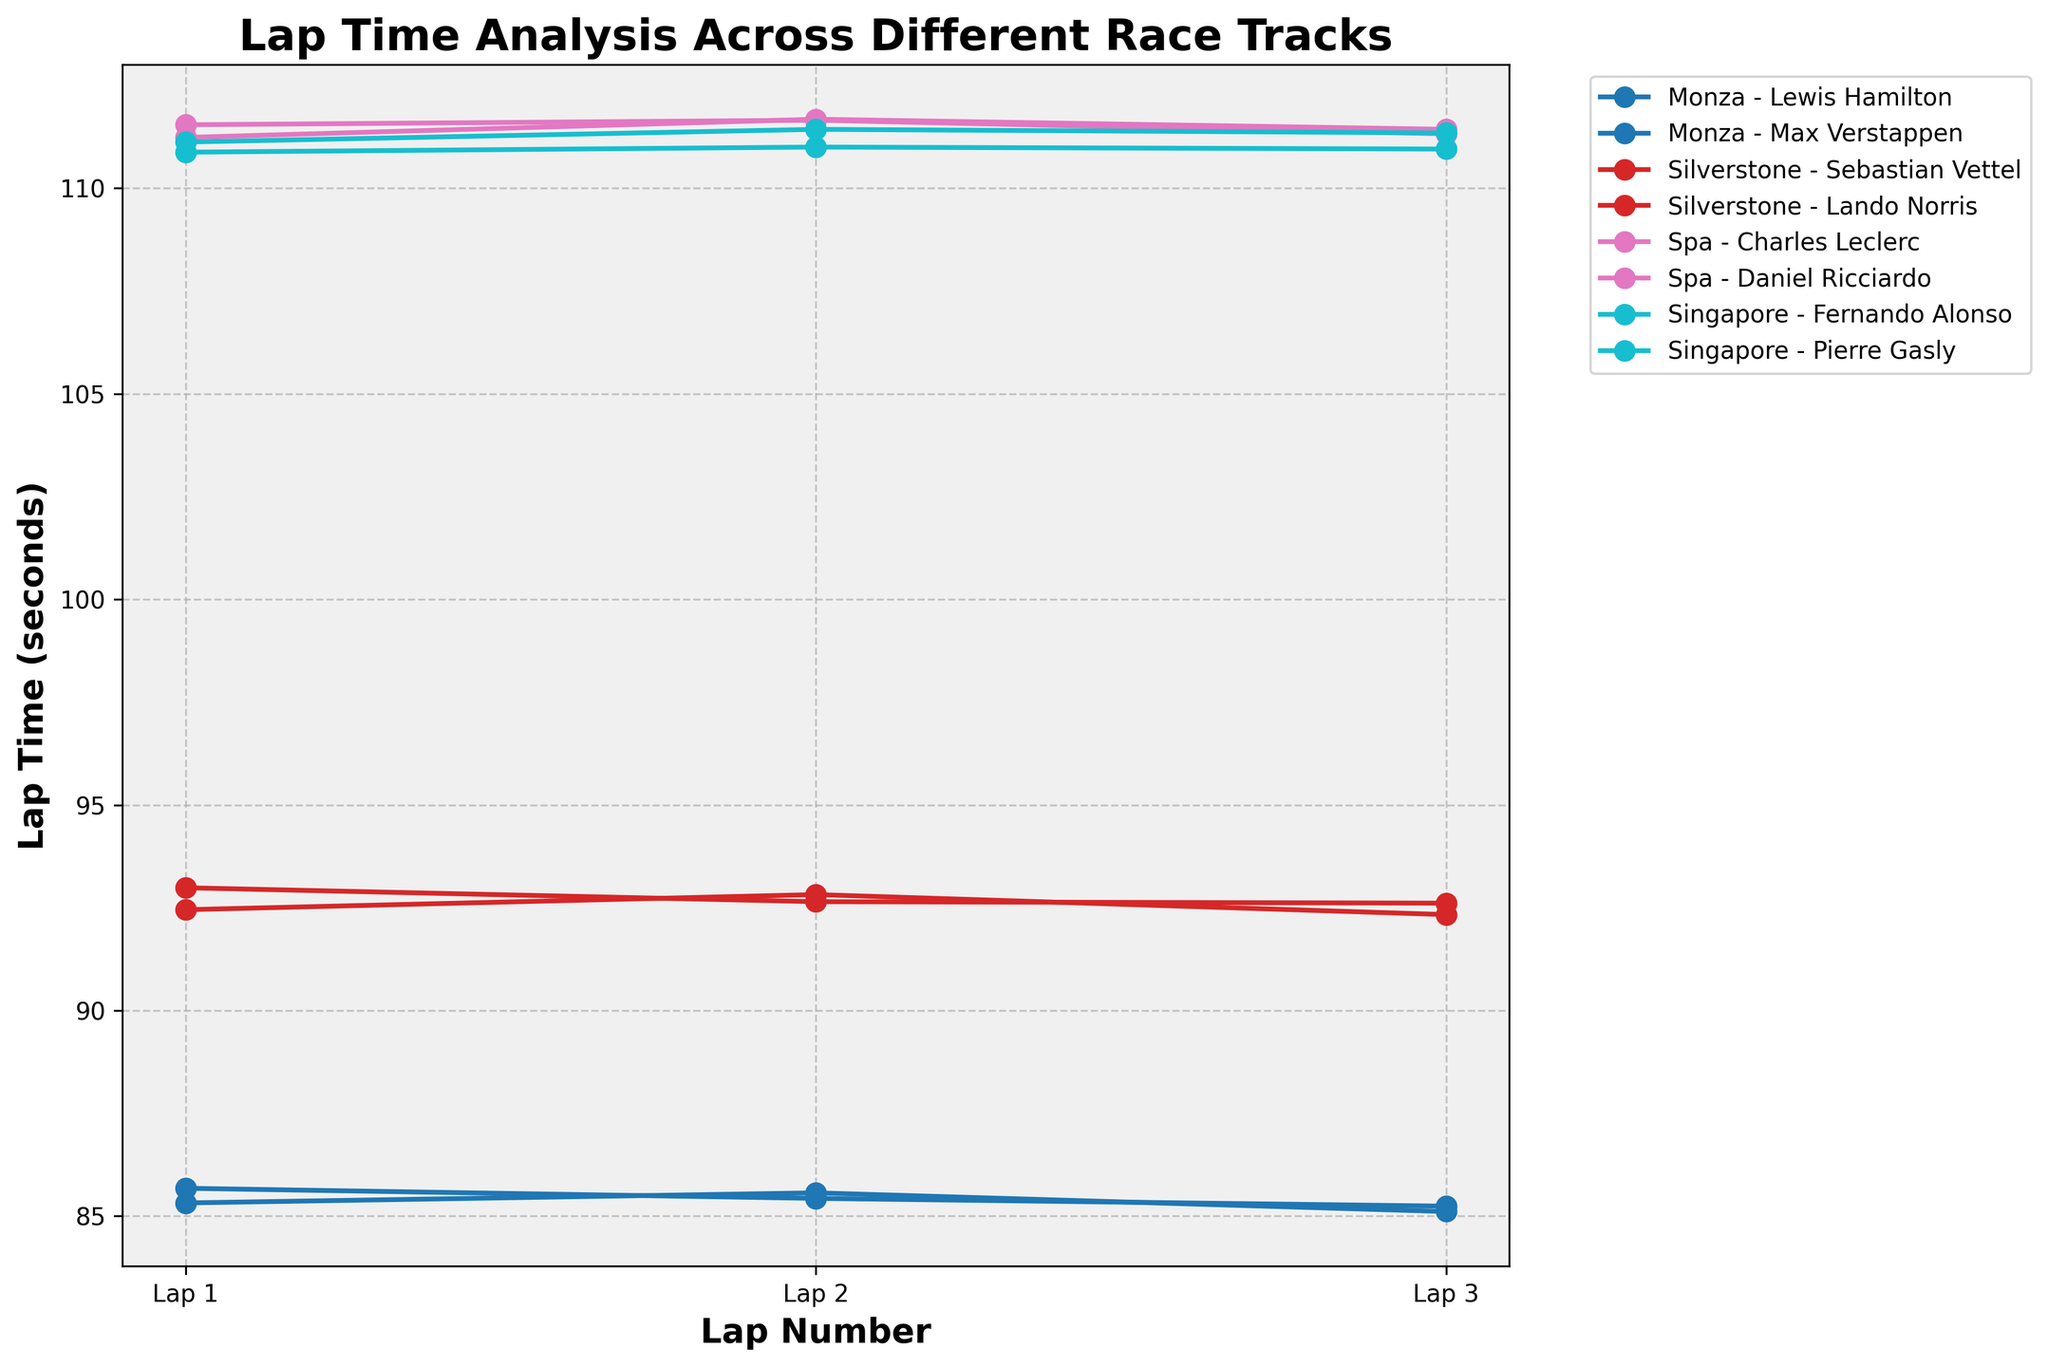Which race has the fastest average lap time? To determine which race has the fastest average lap time, calculate the average lap time for each race and then compare them. Monza has the fastest average lap times.
Answer: Monza Who has the slowest single lap time in Silverstone? Look at the Silverstone lap times for both drivers, and find the highest single lap time. Lando Norris has the slowest with a lap time of 92.987 seconds.
Answer: Lando Norris Which driver shows the most consistent lap times during the race at Monza? To find the most consistent driver, observe who has the smallest variation in lap times for the given laps at Monza. Lewis Hamilton has lap times of 85.321, 85.567, and 85.112, showing less variation compared to Max Verstappen.
Answer: Lewis Hamilton Compare the first Lap times between Charles Leclerc and Daniel Ricciardo at Spa. Who was faster? Look at the lap times for Charles Leclerc and Daniel Ricciardo on the 1st Lap in Spa. Charles Leclerc's first lap time is 111.234 seconds, and Daniel Ricciardo's first lap time is 111.543 seconds. Charles Leclerc is faster.
Answer: Charles Leclerc Which lap did Fernando Alonso perform best at Singapore? Analyze Fernando Alonso's lap times at Singapore, then find the minimum lap time. His best performance is in Lap 1 with a time of 110.876 seconds.
Answer: Lap 1 Calculate the difference in lap times between Sebastian Vettel and Lando Norris on Lap 2 at Silverstone. Both drivers’ lap times at Silverstone on Lap 2 are 92.821 seconds for Vettel and 92.648 seconds for Norris. The difference is 92.821 - 92.648 = 0.173 seconds.
Answer: 0.173 seconds Which race track has the largest average lap time? Calculate the average lap times across all drivers for each race track and identify the highest average. Spa has the highest average lap times.
Answer: Spa During the race at Singapore, who had a slower overall performance, Fernando Alonso or Pierre Gasly? Compare the sum of the three lap times for Fernando Alonso and Pierre Gasly at Singapore. Alonso's total: 110.876 + 111.001 + 110.952 = 332.829 seconds, Gasly's total: 111.123 + 111.432 + 111.345 = 333.900 seconds. Gasly's total lap time is higher, indicating a slower performance.
Answer: Pierre Gasly In which lap did Lewis Hamilton have his fastest lap at Monza? Observe the laps and corresponding times for Lewis Hamilton at Monza, noting the minimum value is 85.112 seconds in Lap 3.
Answer: Lap 3 Which driver shows an improvement in lap time on each successive lap at Monza? Review the drivers' lap times at Monza to find if any driver shows decreasing lap times from Lap 1 to Lap 3. No driver consistently shows improvement across all laps. Both drivers have fluctuating lap times.
Answer: None 